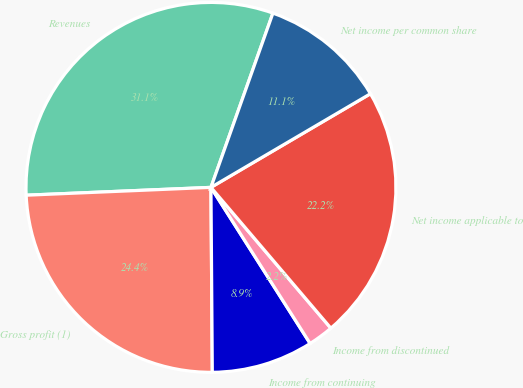Convert chart to OTSL. <chart><loc_0><loc_0><loc_500><loc_500><pie_chart><fcel>Revenues<fcel>Gross profit (1)<fcel>Income from continuing<fcel>Income from discontinued<fcel>Net income applicable to<fcel>Net income per common share<nl><fcel>31.11%<fcel>24.44%<fcel>8.89%<fcel>2.22%<fcel>22.22%<fcel>11.11%<nl></chart> 